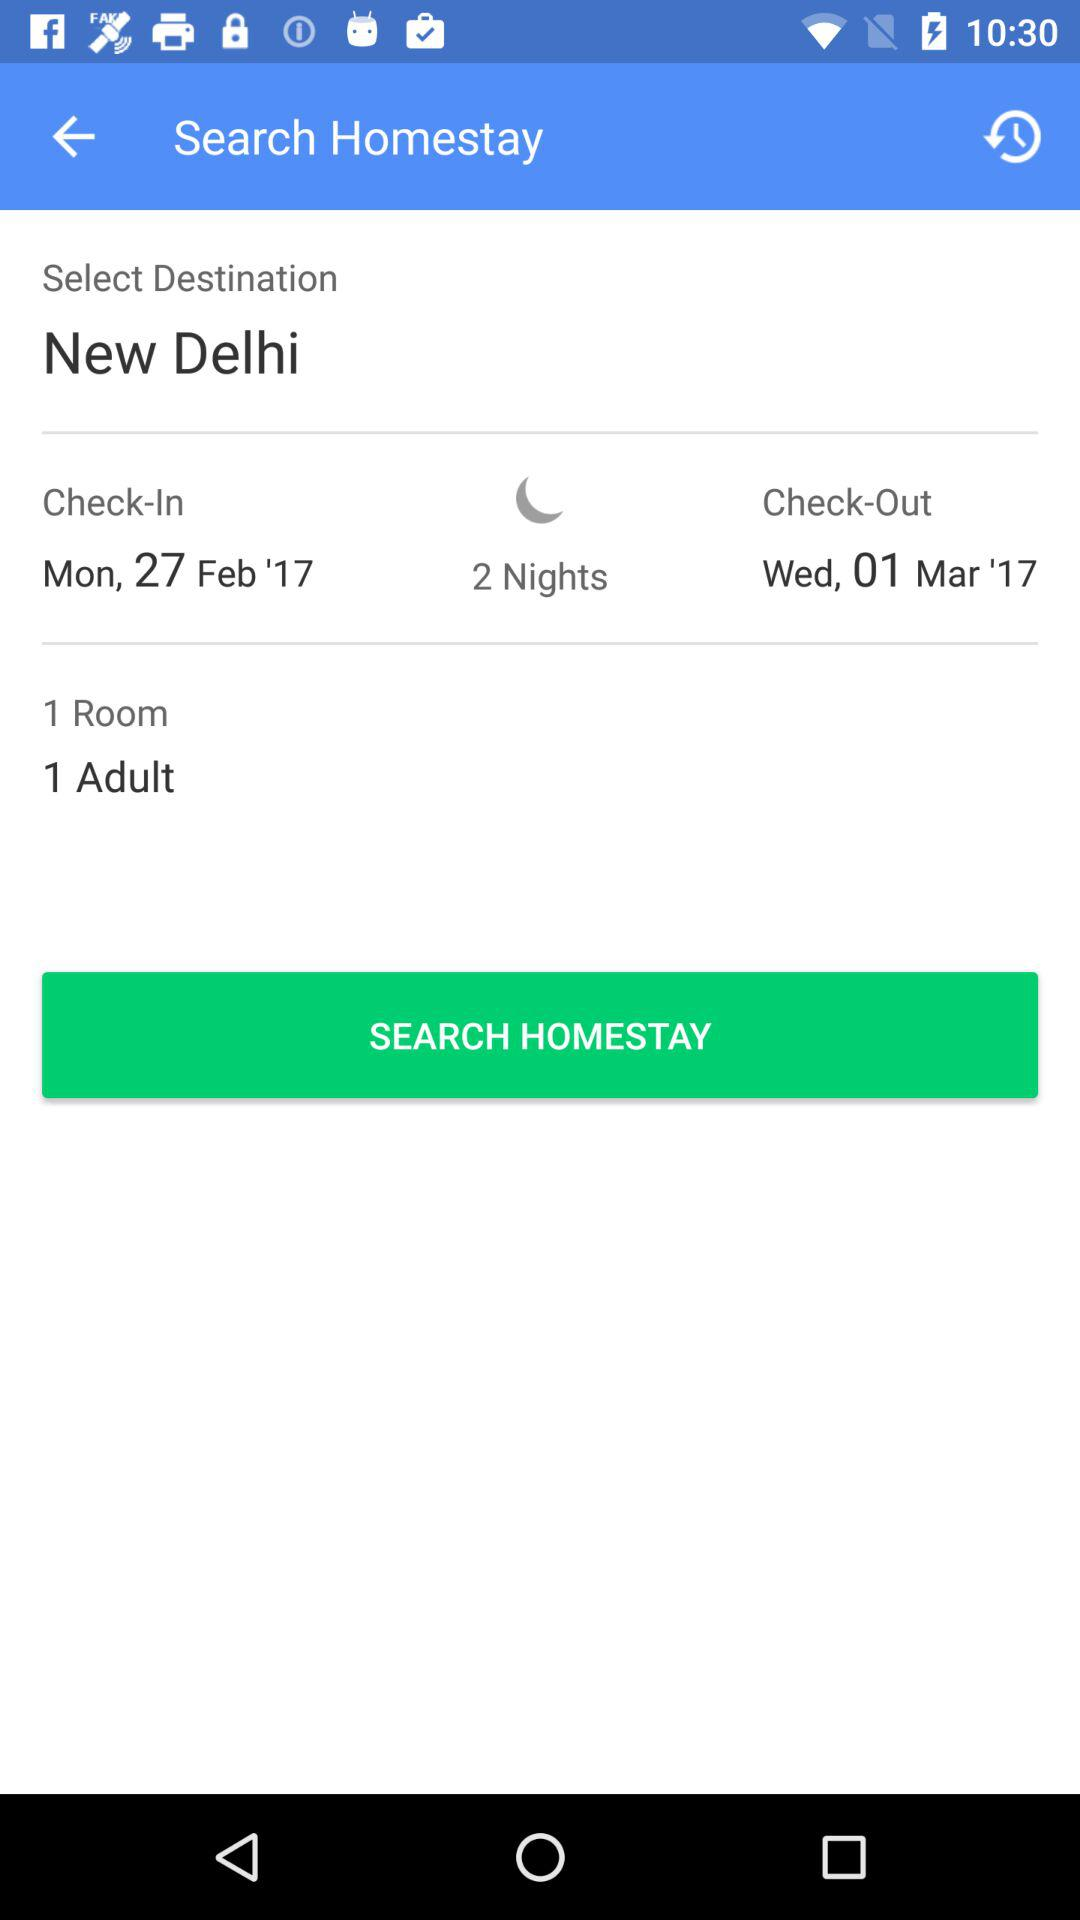How many rooms are there? There is 1 room. 